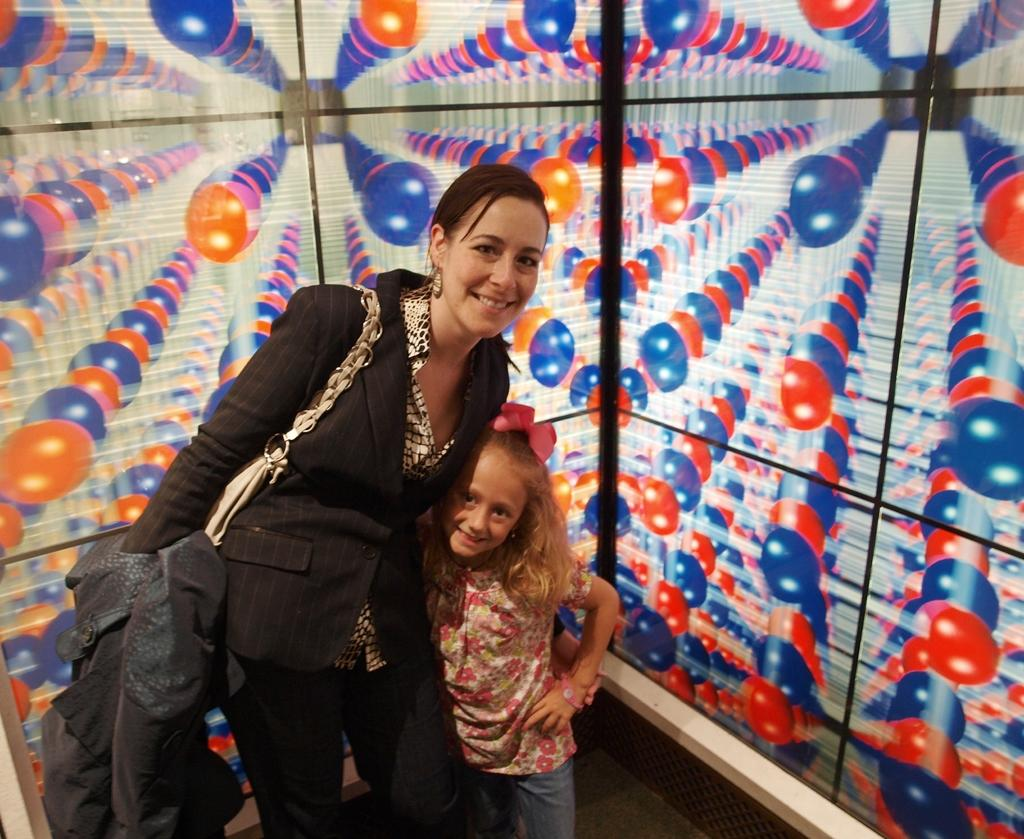Who are the people in the image? There is a woman and a girl in the image. What are the woman and the girl doing in the image? Both the woman and the girl are standing and smiling. What can be seen in the background of the image? There is a colorful wall in the background of the image. What type of celery is the woman holding in the image? There is no celery present in the image. What kind of shoes is the girl wearing in the image? The image does not show the girl's shoes, so it cannot be determined from the image. 